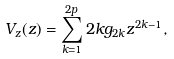<formula> <loc_0><loc_0><loc_500><loc_500>V _ { z } ( z ) = \sum _ { k = 1 } ^ { 2 p } 2 k g _ { 2 k } z ^ { 2 k - 1 } ,</formula> 